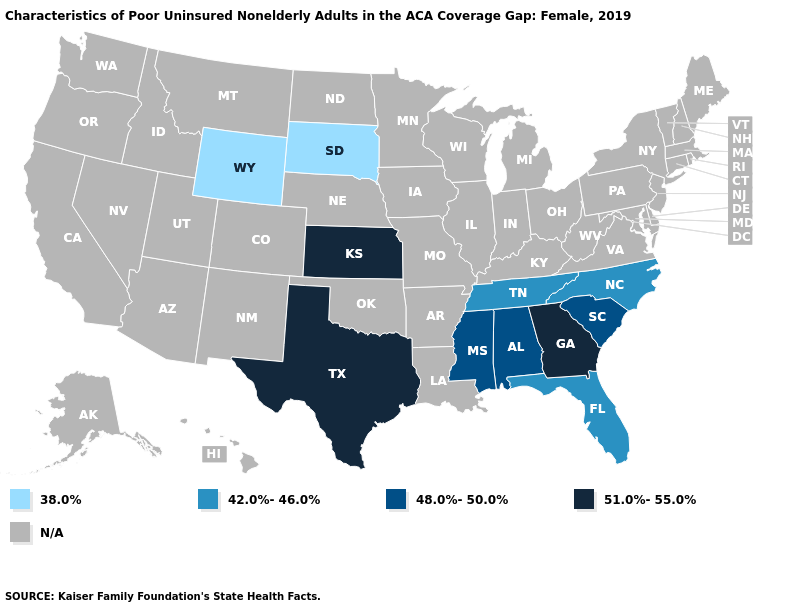Name the states that have a value in the range 51.0%-55.0%?
Keep it brief. Georgia, Kansas, Texas. Which states have the highest value in the USA?
Answer briefly. Georgia, Kansas, Texas. How many symbols are there in the legend?
Be succinct. 5. What is the value of New Mexico?
Short answer required. N/A. Which states have the lowest value in the USA?
Keep it brief. South Dakota, Wyoming. Which states have the lowest value in the West?
Be succinct. Wyoming. Name the states that have a value in the range 48.0%-50.0%?
Short answer required. Alabama, Mississippi, South Carolina. Name the states that have a value in the range 51.0%-55.0%?
Quick response, please. Georgia, Kansas, Texas. What is the value of New York?
Short answer required. N/A. How many symbols are there in the legend?
Write a very short answer. 5. What is the value of Mississippi?
Answer briefly. 48.0%-50.0%. Name the states that have a value in the range 51.0%-55.0%?
Answer briefly. Georgia, Kansas, Texas. 